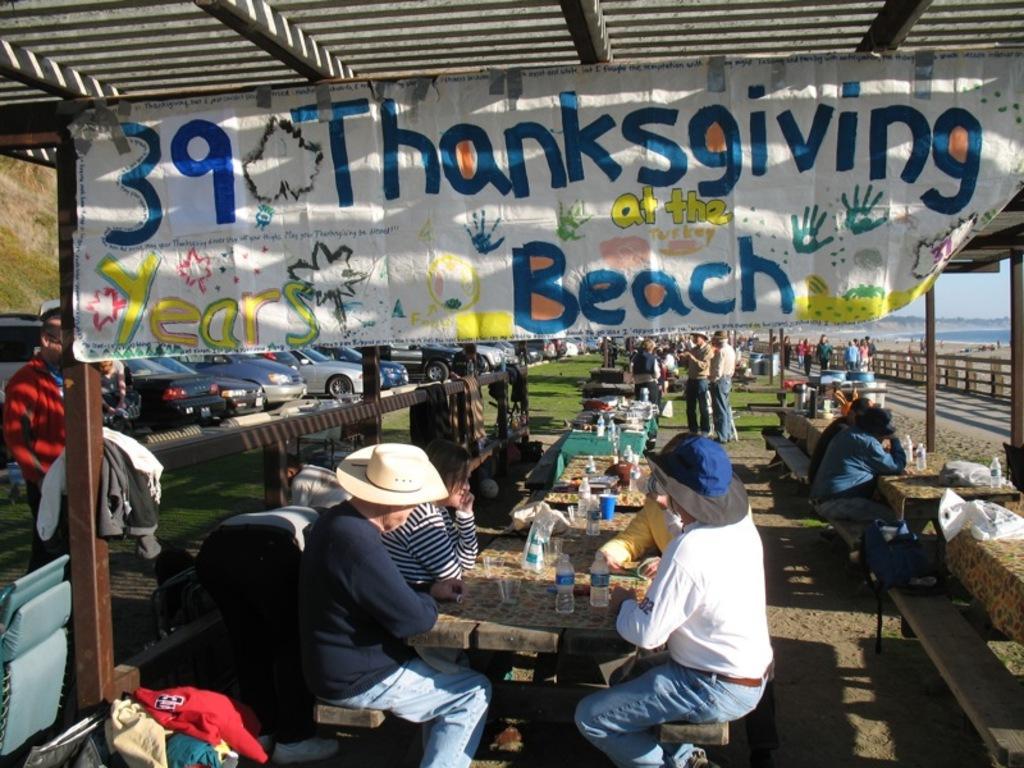Can you describe this image briefly? In this image we can see people sitting on benches. There are objects on the table. At the top of the image there is ceiling. There is a banner with some text. At the bottom of the image there is sand. In the background of the image there are people, cars, grass, fencing. 